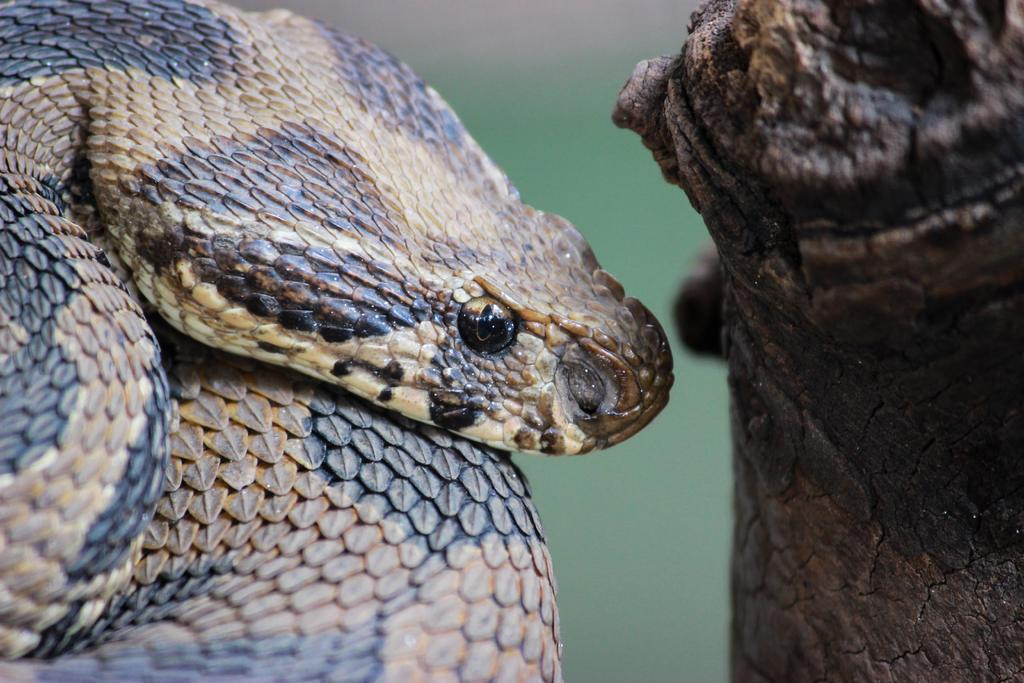What is the main subject in the middle of the image? There is a snake in the middle of the image. What can be seen on the right side of the image? There is a tree trunk on the right side of the image. How would you describe the background of the image? The background of the image is blurred. What type of sugar can be seen in the cave in the image? There is no cave or sugar present in the image; it features a snake and a tree trunk with a blurred background. 